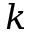<formula> <loc_0><loc_0><loc_500><loc_500>k</formula> 